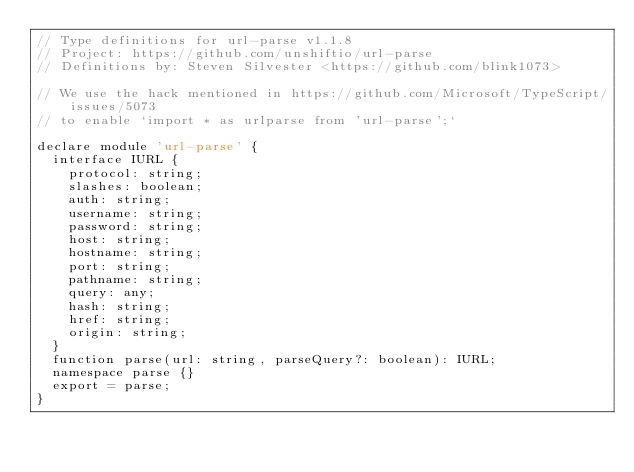Convert code to text. <code><loc_0><loc_0><loc_500><loc_500><_TypeScript_>// Type definitions for url-parse v1.1.8
// Project: https://github.com/unshiftio/url-parse
// Definitions by: Steven Silvester <https://github.com/blink1073>

// We use the hack mentioned in https://github.com/Microsoft/TypeScript/issues/5073
// to enable `import * as urlparse from 'url-parse';`

declare module 'url-parse' {
  interface IURL {
    protocol: string;
    slashes: boolean;
    auth: string;
    username: string;
    password: string;
    host: string;
    hostname: string;
    port: string;
    pathname: string;
    query: any;
    hash: string;
    href: string;
    origin: string;
  }
  function parse(url: string, parseQuery?: boolean): IURL;
  namespace parse {}
  export = parse;
}
</code> 